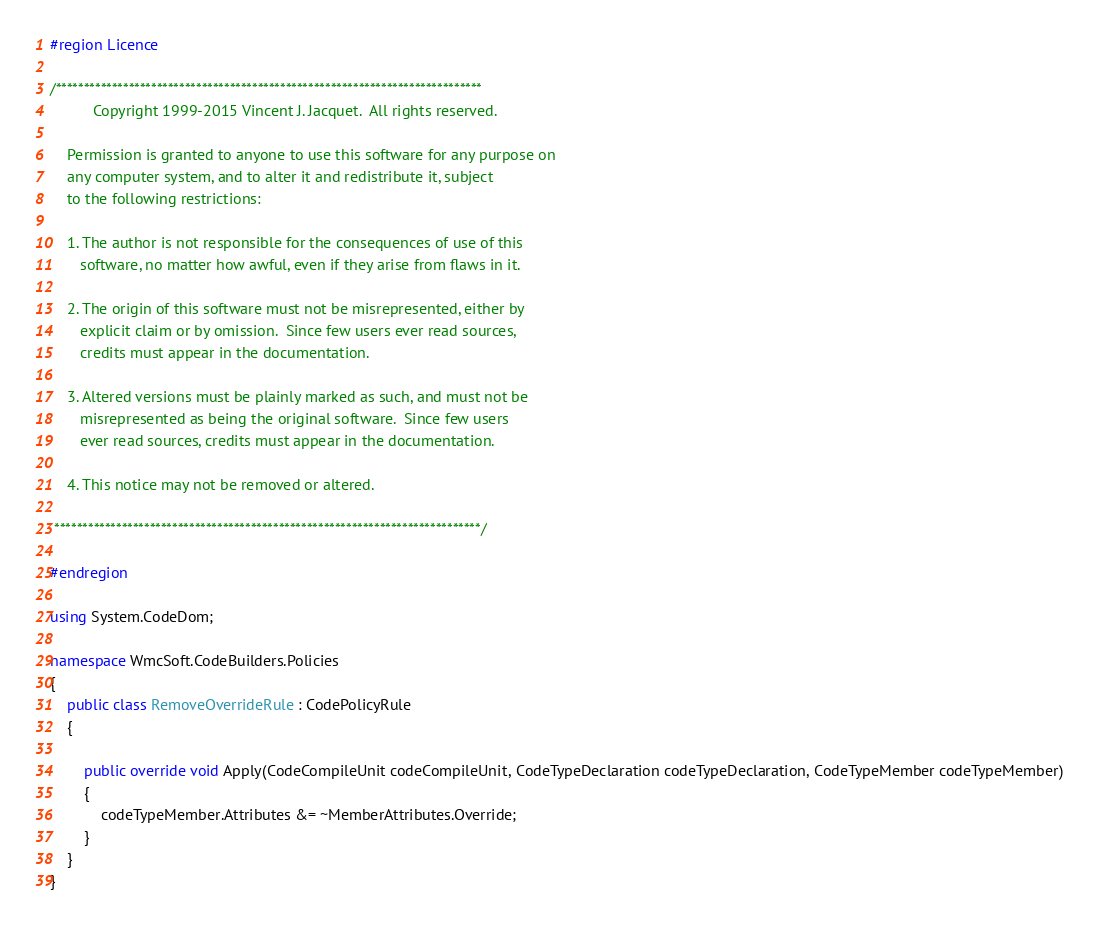<code> <loc_0><loc_0><loc_500><loc_500><_C#_>#region Licence

/****************************************************************************
          Copyright 1999-2015 Vincent J. Jacquet.  All rights reserved.

    Permission is granted to anyone to use this software for any purpose on
    any computer system, and to alter it and redistribute it, subject
    to the following restrictions:

    1. The author is not responsible for the consequences of use of this
       software, no matter how awful, even if they arise from flaws in it.

    2. The origin of this software must not be misrepresented, either by
       explicit claim or by omission.  Since few users ever read sources,
       credits must appear in the documentation.

    3. Altered versions must be plainly marked as such, and must not be
       misrepresented as being the original software.  Since few users
       ever read sources, credits must appear in the documentation.

    4. This notice may not be removed or altered.

 ****************************************************************************/

#endregion

using System.CodeDom;

namespace WmcSoft.CodeBuilders.Policies
{
    public class RemoveOverrideRule : CodePolicyRule
    {

        public override void Apply(CodeCompileUnit codeCompileUnit, CodeTypeDeclaration codeTypeDeclaration, CodeTypeMember codeTypeMember)
        {
            codeTypeMember.Attributes &= ~MemberAttributes.Override;
        }
    }
}
</code> 